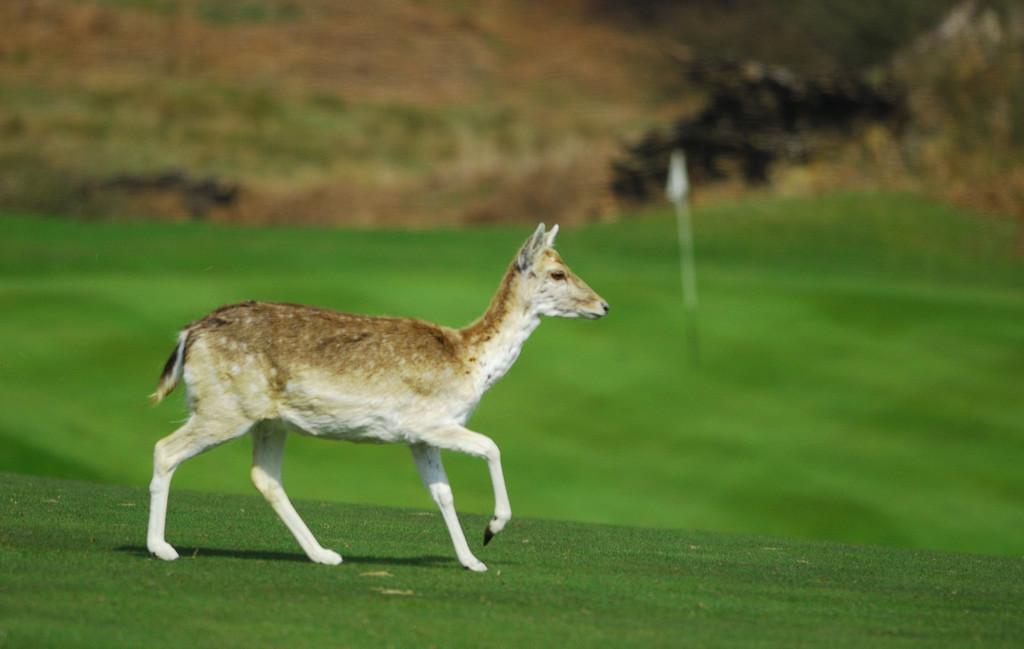In one or two sentences, can you explain what this image depicts? In the foreground of this image, there is a deer walking on the grass and in the background, there is flag on the grass and on the top of the image is blurred. 